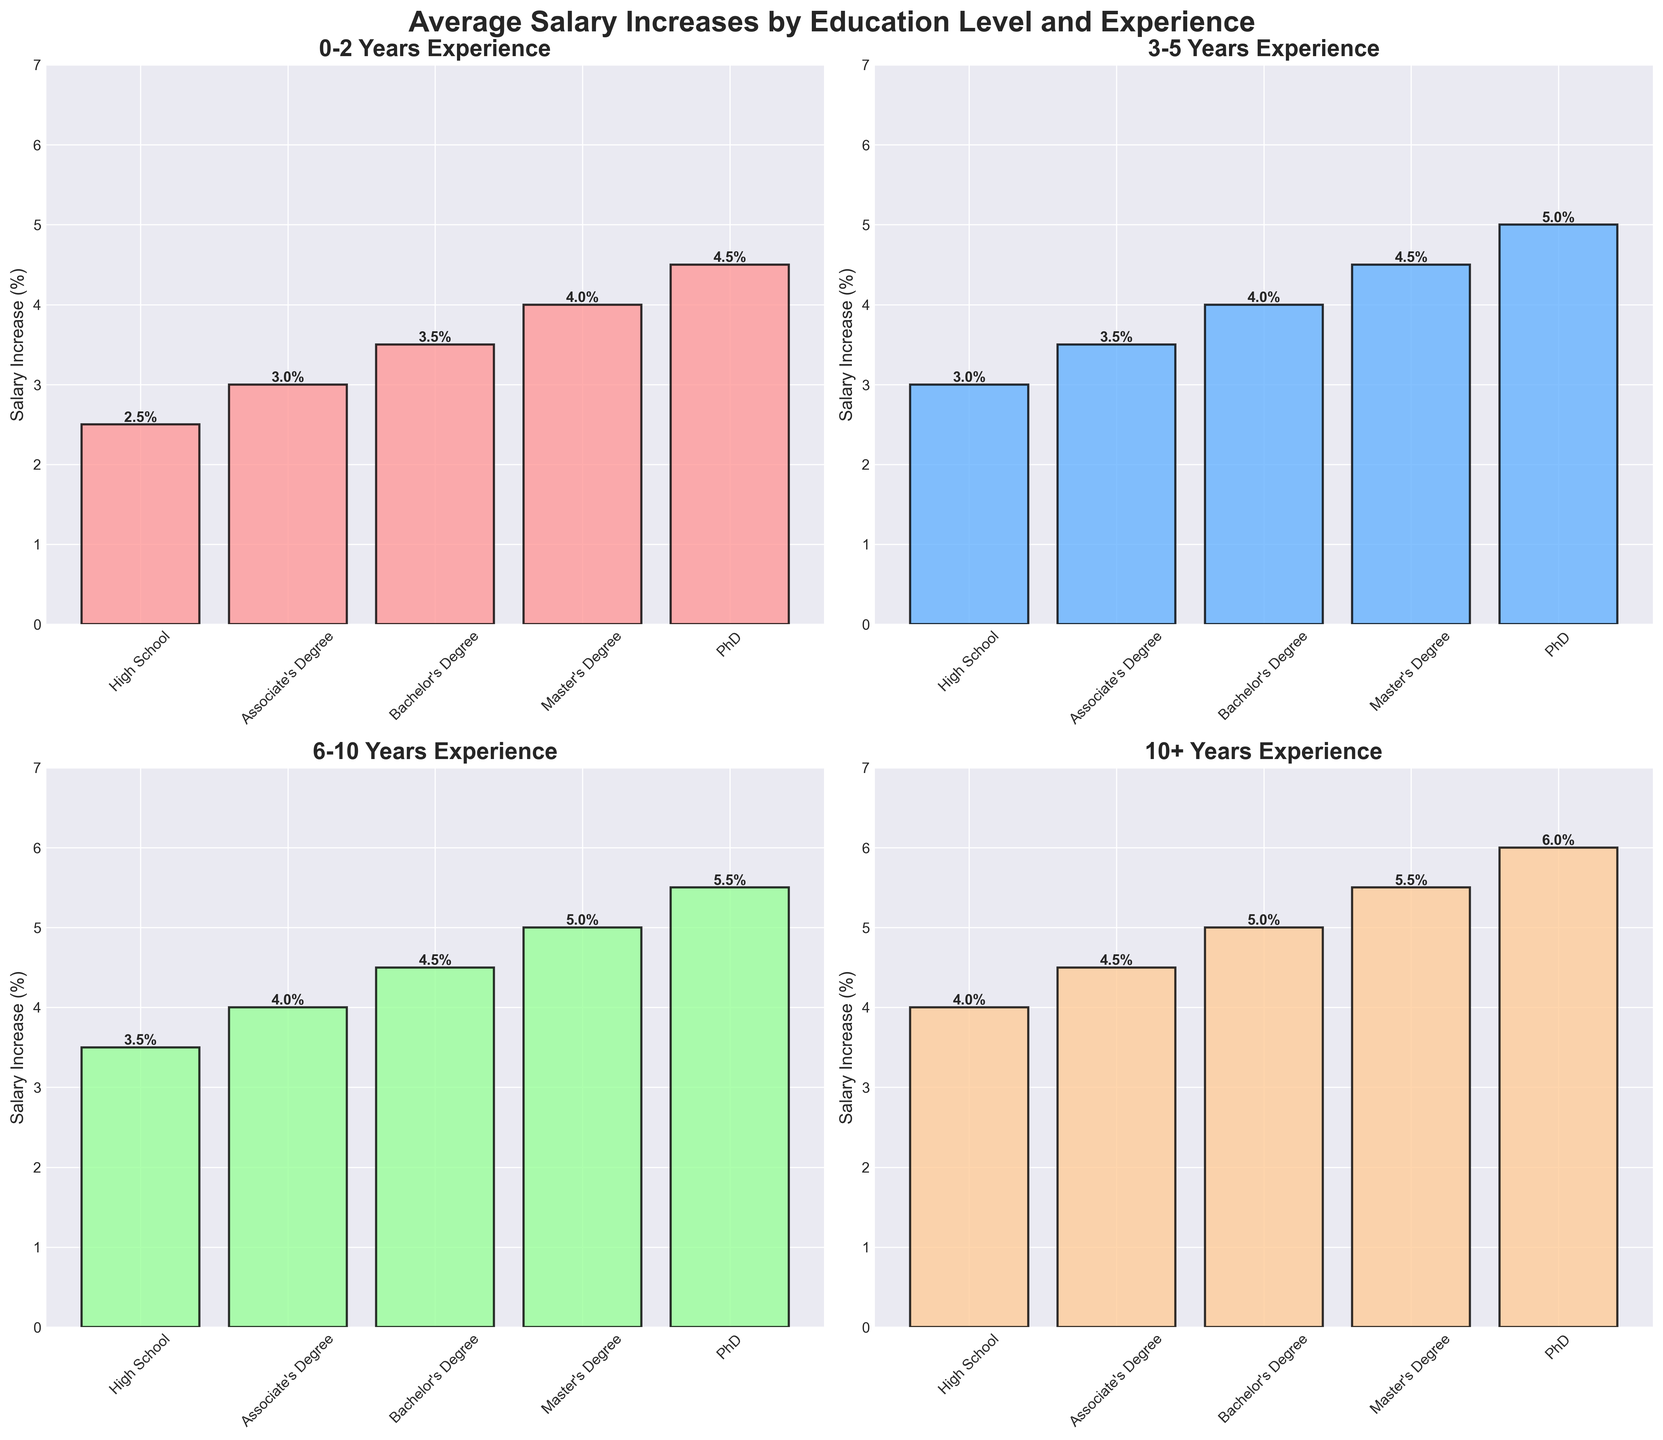What is the title of the figure? The title is usually located at the top of the plot and reads: "Average Salary Increases by Education Level and Experience."
Answer: Average Salary Increases by Education Level and Experience Which education level has the highest salary increase for 10+ years of experience? Look at the subplot with the title "10+ Years Experience" and identify the tallest bar, which belongs to the PhD category.
Answer: PhD What is the salary increase percentage for Bachelor's Degree holders with 3-5 years of experience? Look at the subplot titled "3-5 Years Experience" and locate the bar corresponding to Bachelor's Degree, then read the label at the top of the bar, which shows 4.0%.
Answer: 4.0% By how much does the salary increase percentage for a Bachelor's Degree change between 0-2 years and 10+ years of experience? Find the bars for Bachelor's Degree in "0-2 Years Experience" and "10+ Years Experience" subplots. The heights are 3.5% and 5.0% respectively. Calculate the difference: 5.0% - 3.5% = 1.5%.
Answer: 1.5% Which experience level has the smallest salary increase for High School education? Check all subplots for the "High School" category and find the shortest bar. In "0-2 Years Experience" the increase is 2.5%, which is the smallest.
Answer: 0-2 Years Compare the salary increase for Master's Degree holders between 6-10 years and 10+ years of experience. Which is higher and by how much? Look at the "Master’s Degree" bars in "6-10 Years Experience" and "10+ Years Experience" subplots. The heights are 5.0% and 5.5% respectively. Calculate the difference: 5.5% - 5.0% = 0.5%. The 10+ years increase is higher by 0.5%.
Answer: 10+ years, 0.5% What is the average salary increase percentage for Associate's Degree holders across all experience levels? Identify the heights of the "Associate’s Degree" bars in all subplots: 3.0%, 3.5%, 4.0%, and 4.5%. Sum them up (3.0 + 3.5 + 4.0 + 4.5 = 15.0) and divide by 4 (15.0 / 4 = 3.75%).
Answer: 3.75% How does the salary increase for a PhD at 6-10 years compare to a High School at 10+ years of experience? Locate the bars for "PhD" in the "6-10 Years Experience" subplot and "High School" in the "10+ Years Experience" subplot. Their heights are 5.5% and 4.0% respectively. PhD at 6-10 years is higher by 1.5%.
Answer: PhD at 6-10 years is higher by 1.5% What overall trend can be observed in salary increases based on years of experience for all education levels? Generally, look at all the subplots. Notice that as the years of experience increase from "0-2 Years" to "10+ Years," the salary increase percentages also increase for all education levels.
Answer: Salary increases with more years of experience for all education levels 